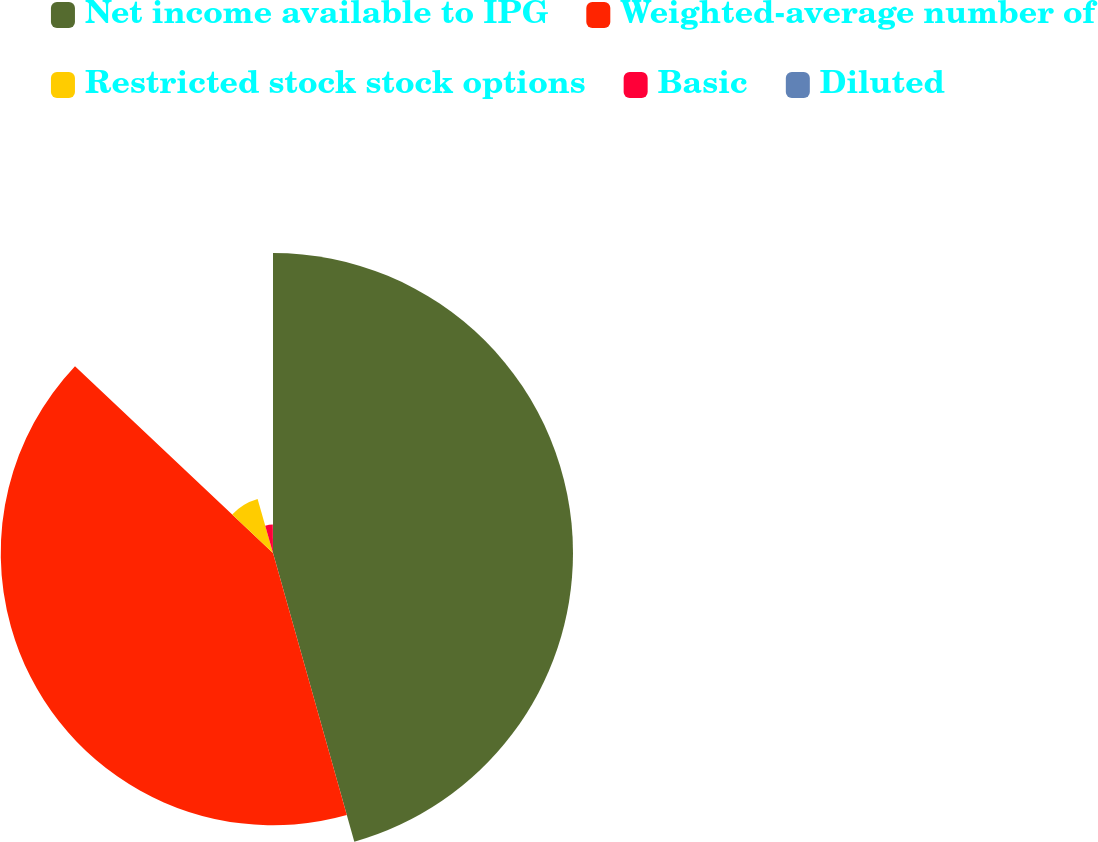Convert chart. <chart><loc_0><loc_0><loc_500><loc_500><pie_chart><fcel>Net income available to IPG<fcel>Weighted-average number of<fcel>Restricted stock stock options<fcel>Basic<fcel>Diluted<nl><fcel>45.63%<fcel>41.41%<fcel>8.54%<fcel>4.32%<fcel>0.1%<nl></chart> 